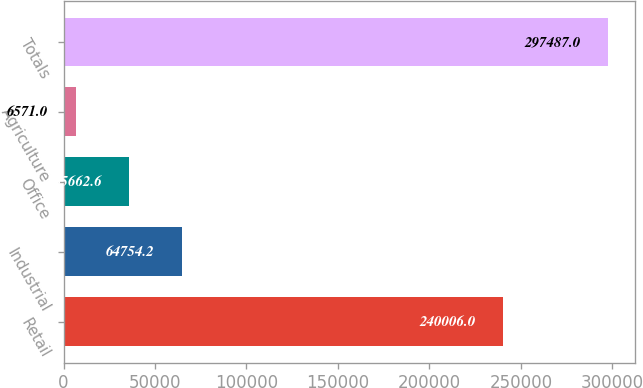Convert chart to OTSL. <chart><loc_0><loc_0><loc_500><loc_500><bar_chart><fcel>Retail<fcel>Industrial<fcel>Office<fcel>Agriculture<fcel>Totals<nl><fcel>240006<fcel>64754.2<fcel>35662.6<fcel>6571<fcel>297487<nl></chart> 